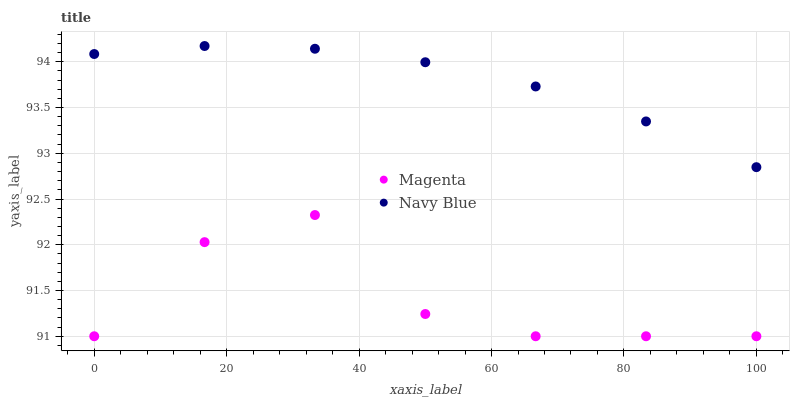Does Magenta have the minimum area under the curve?
Answer yes or no. Yes. Does Navy Blue have the maximum area under the curve?
Answer yes or no. Yes. Does Magenta have the maximum area under the curve?
Answer yes or no. No. Is Navy Blue the smoothest?
Answer yes or no. Yes. Is Magenta the roughest?
Answer yes or no. Yes. Is Magenta the smoothest?
Answer yes or no. No. Does Magenta have the lowest value?
Answer yes or no. Yes. Does Navy Blue have the highest value?
Answer yes or no. Yes. Does Magenta have the highest value?
Answer yes or no. No. Is Magenta less than Navy Blue?
Answer yes or no. Yes. Is Navy Blue greater than Magenta?
Answer yes or no. Yes. Does Magenta intersect Navy Blue?
Answer yes or no. No. 